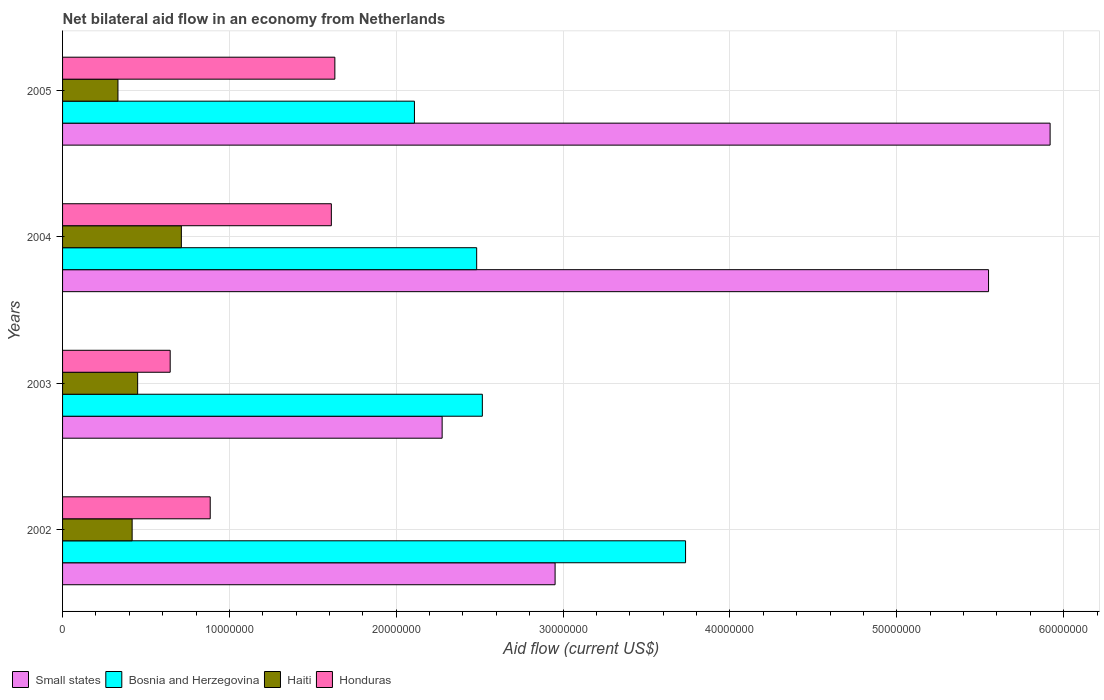How many different coloured bars are there?
Provide a succinct answer. 4. How many groups of bars are there?
Offer a very short reply. 4. Are the number of bars on each tick of the Y-axis equal?
Make the answer very short. Yes. How many bars are there on the 2nd tick from the top?
Your response must be concise. 4. What is the net bilateral aid flow in Small states in 2003?
Provide a succinct answer. 2.28e+07. Across all years, what is the maximum net bilateral aid flow in Haiti?
Offer a very short reply. 7.12e+06. Across all years, what is the minimum net bilateral aid flow in Small states?
Provide a succinct answer. 2.28e+07. What is the total net bilateral aid flow in Haiti in the graph?
Give a very brief answer. 1.91e+07. What is the difference between the net bilateral aid flow in Honduras in 2004 and that in 2005?
Your response must be concise. -2.10e+05. What is the difference between the net bilateral aid flow in Haiti in 2005 and the net bilateral aid flow in Bosnia and Herzegovina in 2002?
Make the answer very short. -3.40e+07. What is the average net bilateral aid flow in Bosnia and Herzegovina per year?
Your answer should be compact. 2.71e+07. In the year 2002, what is the difference between the net bilateral aid flow in Honduras and net bilateral aid flow in Bosnia and Herzegovina?
Give a very brief answer. -2.85e+07. In how many years, is the net bilateral aid flow in Bosnia and Herzegovina greater than 28000000 US$?
Offer a terse response. 1. What is the ratio of the net bilateral aid flow in Honduras in 2002 to that in 2003?
Offer a very short reply. 1.37. What is the difference between the highest and the second highest net bilateral aid flow in Small states?
Your answer should be compact. 3.69e+06. What is the difference between the highest and the lowest net bilateral aid flow in Small states?
Keep it short and to the point. 3.64e+07. In how many years, is the net bilateral aid flow in Honduras greater than the average net bilateral aid flow in Honduras taken over all years?
Provide a short and direct response. 2. Is the sum of the net bilateral aid flow in Honduras in 2002 and 2005 greater than the maximum net bilateral aid flow in Small states across all years?
Your response must be concise. No. Is it the case that in every year, the sum of the net bilateral aid flow in Bosnia and Herzegovina and net bilateral aid flow in Haiti is greater than the sum of net bilateral aid flow in Honduras and net bilateral aid flow in Small states?
Your response must be concise. No. What does the 1st bar from the top in 2003 represents?
Your answer should be very brief. Honduras. What does the 3rd bar from the bottom in 2003 represents?
Provide a succinct answer. Haiti. Is it the case that in every year, the sum of the net bilateral aid flow in Haiti and net bilateral aid flow in Small states is greater than the net bilateral aid flow in Honduras?
Provide a succinct answer. Yes. How many bars are there?
Offer a terse response. 16. Are all the bars in the graph horizontal?
Make the answer very short. Yes. What is the difference between two consecutive major ticks on the X-axis?
Provide a succinct answer. 1.00e+07. Does the graph contain any zero values?
Provide a succinct answer. No. Does the graph contain grids?
Provide a succinct answer. Yes. How many legend labels are there?
Offer a terse response. 4. How are the legend labels stacked?
Offer a terse response. Horizontal. What is the title of the graph?
Make the answer very short. Net bilateral aid flow in an economy from Netherlands. What is the label or title of the Y-axis?
Provide a short and direct response. Years. What is the Aid flow (current US$) in Small states in 2002?
Keep it short and to the point. 2.95e+07. What is the Aid flow (current US$) of Bosnia and Herzegovina in 2002?
Offer a very short reply. 3.73e+07. What is the Aid flow (current US$) of Haiti in 2002?
Keep it short and to the point. 4.17e+06. What is the Aid flow (current US$) in Honduras in 2002?
Give a very brief answer. 8.85e+06. What is the Aid flow (current US$) in Small states in 2003?
Make the answer very short. 2.28e+07. What is the Aid flow (current US$) in Bosnia and Herzegovina in 2003?
Your answer should be compact. 2.52e+07. What is the Aid flow (current US$) in Haiti in 2003?
Make the answer very short. 4.50e+06. What is the Aid flow (current US$) in Honduras in 2003?
Offer a very short reply. 6.45e+06. What is the Aid flow (current US$) of Small states in 2004?
Offer a very short reply. 5.55e+07. What is the Aid flow (current US$) of Bosnia and Herzegovina in 2004?
Make the answer very short. 2.48e+07. What is the Aid flow (current US$) in Haiti in 2004?
Ensure brevity in your answer.  7.12e+06. What is the Aid flow (current US$) in Honduras in 2004?
Ensure brevity in your answer.  1.61e+07. What is the Aid flow (current US$) of Small states in 2005?
Provide a succinct answer. 5.92e+07. What is the Aid flow (current US$) of Bosnia and Herzegovina in 2005?
Give a very brief answer. 2.11e+07. What is the Aid flow (current US$) of Haiti in 2005?
Provide a short and direct response. 3.32e+06. What is the Aid flow (current US$) of Honduras in 2005?
Your response must be concise. 1.63e+07. Across all years, what is the maximum Aid flow (current US$) of Small states?
Make the answer very short. 5.92e+07. Across all years, what is the maximum Aid flow (current US$) of Bosnia and Herzegovina?
Offer a very short reply. 3.73e+07. Across all years, what is the maximum Aid flow (current US$) of Haiti?
Offer a very short reply. 7.12e+06. Across all years, what is the maximum Aid flow (current US$) of Honduras?
Your answer should be compact. 1.63e+07. Across all years, what is the minimum Aid flow (current US$) in Small states?
Your response must be concise. 2.28e+07. Across all years, what is the minimum Aid flow (current US$) in Bosnia and Herzegovina?
Your answer should be very brief. 2.11e+07. Across all years, what is the minimum Aid flow (current US$) of Haiti?
Offer a terse response. 3.32e+06. Across all years, what is the minimum Aid flow (current US$) in Honduras?
Give a very brief answer. 6.45e+06. What is the total Aid flow (current US$) of Small states in the graph?
Provide a succinct answer. 1.67e+08. What is the total Aid flow (current US$) of Bosnia and Herzegovina in the graph?
Offer a very short reply. 1.08e+08. What is the total Aid flow (current US$) of Haiti in the graph?
Make the answer very short. 1.91e+07. What is the total Aid flow (current US$) of Honduras in the graph?
Ensure brevity in your answer.  4.77e+07. What is the difference between the Aid flow (current US$) of Small states in 2002 and that in 2003?
Provide a succinct answer. 6.77e+06. What is the difference between the Aid flow (current US$) of Bosnia and Herzegovina in 2002 and that in 2003?
Provide a succinct answer. 1.22e+07. What is the difference between the Aid flow (current US$) in Haiti in 2002 and that in 2003?
Offer a very short reply. -3.30e+05. What is the difference between the Aid flow (current US$) of Honduras in 2002 and that in 2003?
Offer a terse response. 2.40e+06. What is the difference between the Aid flow (current US$) in Small states in 2002 and that in 2004?
Offer a very short reply. -2.60e+07. What is the difference between the Aid flow (current US$) in Bosnia and Herzegovina in 2002 and that in 2004?
Offer a terse response. 1.25e+07. What is the difference between the Aid flow (current US$) in Haiti in 2002 and that in 2004?
Give a very brief answer. -2.95e+06. What is the difference between the Aid flow (current US$) of Honduras in 2002 and that in 2004?
Your response must be concise. -7.26e+06. What is the difference between the Aid flow (current US$) in Small states in 2002 and that in 2005?
Keep it short and to the point. -2.97e+07. What is the difference between the Aid flow (current US$) in Bosnia and Herzegovina in 2002 and that in 2005?
Give a very brief answer. 1.62e+07. What is the difference between the Aid flow (current US$) in Haiti in 2002 and that in 2005?
Make the answer very short. 8.50e+05. What is the difference between the Aid flow (current US$) in Honduras in 2002 and that in 2005?
Your answer should be very brief. -7.47e+06. What is the difference between the Aid flow (current US$) in Small states in 2003 and that in 2004?
Ensure brevity in your answer.  -3.28e+07. What is the difference between the Aid flow (current US$) in Bosnia and Herzegovina in 2003 and that in 2004?
Provide a short and direct response. 3.40e+05. What is the difference between the Aid flow (current US$) of Haiti in 2003 and that in 2004?
Make the answer very short. -2.62e+06. What is the difference between the Aid flow (current US$) in Honduras in 2003 and that in 2004?
Give a very brief answer. -9.66e+06. What is the difference between the Aid flow (current US$) in Small states in 2003 and that in 2005?
Your answer should be very brief. -3.64e+07. What is the difference between the Aid flow (current US$) in Bosnia and Herzegovina in 2003 and that in 2005?
Your response must be concise. 4.07e+06. What is the difference between the Aid flow (current US$) in Haiti in 2003 and that in 2005?
Your answer should be compact. 1.18e+06. What is the difference between the Aid flow (current US$) in Honduras in 2003 and that in 2005?
Offer a very short reply. -9.87e+06. What is the difference between the Aid flow (current US$) in Small states in 2004 and that in 2005?
Offer a terse response. -3.69e+06. What is the difference between the Aid flow (current US$) in Bosnia and Herzegovina in 2004 and that in 2005?
Keep it short and to the point. 3.73e+06. What is the difference between the Aid flow (current US$) in Haiti in 2004 and that in 2005?
Your response must be concise. 3.80e+06. What is the difference between the Aid flow (current US$) of Honduras in 2004 and that in 2005?
Your response must be concise. -2.10e+05. What is the difference between the Aid flow (current US$) in Small states in 2002 and the Aid flow (current US$) in Bosnia and Herzegovina in 2003?
Make the answer very short. 4.36e+06. What is the difference between the Aid flow (current US$) of Small states in 2002 and the Aid flow (current US$) of Haiti in 2003?
Ensure brevity in your answer.  2.50e+07. What is the difference between the Aid flow (current US$) of Small states in 2002 and the Aid flow (current US$) of Honduras in 2003?
Offer a terse response. 2.31e+07. What is the difference between the Aid flow (current US$) of Bosnia and Herzegovina in 2002 and the Aid flow (current US$) of Haiti in 2003?
Your answer should be compact. 3.28e+07. What is the difference between the Aid flow (current US$) in Bosnia and Herzegovina in 2002 and the Aid flow (current US$) in Honduras in 2003?
Ensure brevity in your answer.  3.09e+07. What is the difference between the Aid flow (current US$) in Haiti in 2002 and the Aid flow (current US$) in Honduras in 2003?
Provide a succinct answer. -2.28e+06. What is the difference between the Aid flow (current US$) of Small states in 2002 and the Aid flow (current US$) of Bosnia and Herzegovina in 2004?
Your response must be concise. 4.70e+06. What is the difference between the Aid flow (current US$) of Small states in 2002 and the Aid flow (current US$) of Haiti in 2004?
Give a very brief answer. 2.24e+07. What is the difference between the Aid flow (current US$) in Small states in 2002 and the Aid flow (current US$) in Honduras in 2004?
Keep it short and to the point. 1.34e+07. What is the difference between the Aid flow (current US$) in Bosnia and Herzegovina in 2002 and the Aid flow (current US$) in Haiti in 2004?
Your answer should be very brief. 3.02e+07. What is the difference between the Aid flow (current US$) of Bosnia and Herzegovina in 2002 and the Aid flow (current US$) of Honduras in 2004?
Keep it short and to the point. 2.12e+07. What is the difference between the Aid flow (current US$) of Haiti in 2002 and the Aid flow (current US$) of Honduras in 2004?
Give a very brief answer. -1.19e+07. What is the difference between the Aid flow (current US$) of Small states in 2002 and the Aid flow (current US$) of Bosnia and Herzegovina in 2005?
Provide a short and direct response. 8.43e+06. What is the difference between the Aid flow (current US$) in Small states in 2002 and the Aid flow (current US$) in Haiti in 2005?
Provide a short and direct response. 2.62e+07. What is the difference between the Aid flow (current US$) in Small states in 2002 and the Aid flow (current US$) in Honduras in 2005?
Your response must be concise. 1.32e+07. What is the difference between the Aid flow (current US$) of Bosnia and Herzegovina in 2002 and the Aid flow (current US$) of Haiti in 2005?
Ensure brevity in your answer.  3.40e+07. What is the difference between the Aid flow (current US$) in Bosnia and Herzegovina in 2002 and the Aid flow (current US$) in Honduras in 2005?
Keep it short and to the point. 2.10e+07. What is the difference between the Aid flow (current US$) in Haiti in 2002 and the Aid flow (current US$) in Honduras in 2005?
Offer a very short reply. -1.22e+07. What is the difference between the Aid flow (current US$) in Small states in 2003 and the Aid flow (current US$) in Bosnia and Herzegovina in 2004?
Ensure brevity in your answer.  -2.07e+06. What is the difference between the Aid flow (current US$) in Small states in 2003 and the Aid flow (current US$) in Haiti in 2004?
Offer a terse response. 1.56e+07. What is the difference between the Aid flow (current US$) of Small states in 2003 and the Aid flow (current US$) of Honduras in 2004?
Ensure brevity in your answer.  6.64e+06. What is the difference between the Aid flow (current US$) of Bosnia and Herzegovina in 2003 and the Aid flow (current US$) of Haiti in 2004?
Your response must be concise. 1.80e+07. What is the difference between the Aid flow (current US$) in Bosnia and Herzegovina in 2003 and the Aid flow (current US$) in Honduras in 2004?
Make the answer very short. 9.05e+06. What is the difference between the Aid flow (current US$) in Haiti in 2003 and the Aid flow (current US$) in Honduras in 2004?
Provide a succinct answer. -1.16e+07. What is the difference between the Aid flow (current US$) of Small states in 2003 and the Aid flow (current US$) of Bosnia and Herzegovina in 2005?
Keep it short and to the point. 1.66e+06. What is the difference between the Aid flow (current US$) of Small states in 2003 and the Aid flow (current US$) of Haiti in 2005?
Provide a succinct answer. 1.94e+07. What is the difference between the Aid flow (current US$) of Small states in 2003 and the Aid flow (current US$) of Honduras in 2005?
Your answer should be compact. 6.43e+06. What is the difference between the Aid flow (current US$) in Bosnia and Herzegovina in 2003 and the Aid flow (current US$) in Haiti in 2005?
Offer a very short reply. 2.18e+07. What is the difference between the Aid flow (current US$) of Bosnia and Herzegovina in 2003 and the Aid flow (current US$) of Honduras in 2005?
Your answer should be very brief. 8.84e+06. What is the difference between the Aid flow (current US$) in Haiti in 2003 and the Aid flow (current US$) in Honduras in 2005?
Your response must be concise. -1.18e+07. What is the difference between the Aid flow (current US$) of Small states in 2004 and the Aid flow (current US$) of Bosnia and Herzegovina in 2005?
Offer a very short reply. 3.44e+07. What is the difference between the Aid flow (current US$) of Small states in 2004 and the Aid flow (current US$) of Haiti in 2005?
Your answer should be compact. 5.22e+07. What is the difference between the Aid flow (current US$) in Small states in 2004 and the Aid flow (current US$) in Honduras in 2005?
Offer a very short reply. 3.92e+07. What is the difference between the Aid flow (current US$) in Bosnia and Herzegovina in 2004 and the Aid flow (current US$) in Haiti in 2005?
Provide a short and direct response. 2.15e+07. What is the difference between the Aid flow (current US$) of Bosnia and Herzegovina in 2004 and the Aid flow (current US$) of Honduras in 2005?
Your response must be concise. 8.50e+06. What is the difference between the Aid flow (current US$) of Haiti in 2004 and the Aid flow (current US$) of Honduras in 2005?
Your answer should be very brief. -9.20e+06. What is the average Aid flow (current US$) of Small states per year?
Your answer should be compact. 4.17e+07. What is the average Aid flow (current US$) of Bosnia and Herzegovina per year?
Provide a short and direct response. 2.71e+07. What is the average Aid flow (current US$) of Haiti per year?
Keep it short and to the point. 4.78e+06. What is the average Aid flow (current US$) in Honduras per year?
Your answer should be compact. 1.19e+07. In the year 2002, what is the difference between the Aid flow (current US$) in Small states and Aid flow (current US$) in Bosnia and Herzegovina?
Your answer should be very brief. -7.82e+06. In the year 2002, what is the difference between the Aid flow (current US$) in Small states and Aid flow (current US$) in Haiti?
Your answer should be very brief. 2.54e+07. In the year 2002, what is the difference between the Aid flow (current US$) in Small states and Aid flow (current US$) in Honduras?
Your answer should be very brief. 2.07e+07. In the year 2002, what is the difference between the Aid flow (current US$) in Bosnia and Herzegovina and Aid flow (current US$) in Haiti?
Provide a succinct answer. 3.32e+07. In the year 2002, what is the difference between the Aid flow (current US$) of Bosnia and Herzegovina and Aid flow (current US$) of Honduras?
Offer a very short reply. 2.85e+07. In the year 2002, what is the difference between the Aid flow (current US$) in Haiti and Aid flow (current US$) in Honduras?
Give a very brief answer. -4.68e+06. In the year 2003, what is the difference between the Aid flow (current US$) in Small states and Aid flow (current US$) in Bosnia and Herzegovina?
Your answer should be compact. -2.41e+06. In the year 2003, what is the difference between the Aid flow (current US$) in Small states and Aid flow (current US$) in Haiti?
Offer a terse response. 1.82e+07. In the year 2003, what is the difference between the Aid flow (current US$) in Small states and Aid flow (current US$) in Honduras?
Provide a succinct answer. 1.63e+07. In the year 2003, what is the difference between the Aid flow (current US$) in Bosnia and Herzegovina and Aid flow (current US$) in Haiti?
Your response must be concise. 2.07e+07. In the year 2003, what is the difference between the Aid flow (current US$) in Bosnia and Herzegovina and Aid flow (current US$) in Honduras?
Offer a terse response. 1.87e+07. In the year 2003, what is the difference between the Aid flow (current US$) of Haiti and Aid flow (current US$) of Honduras?
Offer a very short reply. -1.95e+06. In the year 2004, what is the difference between the Aid flow (current US$) in Small states and Aid flow (current US$) in Bosnia and Herzegovina?
Ensure brevity in your answer.  3.07e+07. In the year 2004, what is the difference between the Aid flow (current US$) in Small states and Aid flow (current US$) in Haiti?
Offer a very short reply. 4.84e+07. In the year 2004, what is the difference between the Aid flow (current US$) in Small states and Aid flow (current US$) in Honduras?
Your answer should be very brief. 3.94e+07. In the year 2004, what is the difference between the Aid flow (current US$) of Bosnia and Herzegovina and Aid flow (current US$) of Haiti?
Make the answer very short. 1.77e+07. In the year 2004, what is the difference between the Aid flow (current US$) in Bosnia and Herzegovina and Aid flow (current US$) in Honduras?
Give a very brief answer. 8.71e+06. In the year 2004, what is the difference between the Aid flow (current US$) of Haiti and Aid flow (current US$) of Honduras?
Keep it short and to the point. -8.99e+06. In the year 2005, what is the difference between the Aid flow (current US$) of Small states and Aid flow (current US$) of Bosnia and Herzegovina?
Offer a terse response. 3.81e+07. In the year 2005, what is the difference between the Aid flow (current US$) in Small states and Aid flow (current US$) in Haiti?
Give a very brief answer. 5.59e+07. In the year 2005, what is the difference between the Aid flow (current US$) in Small states and Aid flow (current US$) in Honduras?
Keep it short and to the point. 4.29e+07. In the year 2005, what is the difference between the Aid flow (current US$) of Bosnia and Herzegovina and Aid flow (current US$) of Haiti?
Provide a short and direct response. 1.78e+07. In the year 2005, what is the difference between the Aid flow (current US$) in Bosnia and Herzegovina and Aid flow (current US$) in Honduras?
Give a very brief answer. 4.77e+06. In the year 2005, what is the difference between the Aid flow (current US$) of Haiti and Aid flow (current US$) of Honduras?
Provide a succinct answer. -1.30e+07. What is the ratio of the Aid flow (current US$) of Small states in 2002 to that in 2003?
Your answer should be compact. 1.3. What is the ratio of the Aid flow (current US$) in Bosnia and Herzegovina in 2002 to that in 2003?
Give a very brief answer. 1.48. What is the ratio of the Aid flow (current US$) in Haiti in 2002 to that in 2003?
Your response must be concise. 0.93. What is the ratio of the Aid flow (current US$) in Honduras in 2002 to that in 2003?
Keep it short and to the point. 1.37. What is the ratio of the Aid flow (current US$) in Small states in 2002 to that in 2004?
Offer a very short reply. 0.53. What is the ratio of the Aid flow (current US$) in Bosnia and Herzegovina in 2002 to that in 2004?
Your answer should be very brief. 1.5. What is the ratio of the Aid flow (current US$) in Haiti in 2002 to that in 2004?
Offer a terse response. 0.59. What is the ratio of the Aid flow (current US$) of Honduras in 2002 to that in 2004?
Give a very brief answer. 0.55. What is the ratio of the Aid flow (current US$) in Small states in 2002 to that in 2005?
Ensure brevity in your answer.  0.5. What is the ratio of the Aid flow (current US$) in Bosnia and Herzegovina in 2002 to that in 2005?
Your response must be concise. 1.77. What is the ratio of the Aid flow (current US$) of Haiti in 2002 to that in 2005?
Offer a very short reply. 1.26. What is the ratio of the Aid flow (current US$) of Honduras in 2002 to that in 2005?
Offer a very short reply. 0.54. What is the ratio of the Aid flow (current US$) in Small states in 2003 to that in 2004?
Provide a succinct answer. 0.41. What is the ratio of the Aid flow (current US$) in Bosnia and Herzegovina in 2003 to that in 2004?
Offer a very short reply. 1.01. What is the ratio of the Aid flow (current US$) in Haiti in 2003 to that in 2004?
Offer a very short reply. 0.63. What is the ratio of the Aid flow (current US$) in Honduras in 2003 to that in 2004?
Ensure brevity in your answer.  0.4. What is the ratio of the Aid flow (current US$) in Small states in 2003 to that in 2005?
Offer a very short reply. 0.38. What is the ratio of the Aid flow (current US$) in Bosnia and Herzegovina in 2003 to that in 2005?
Your answer should be compact. 1.19. What is the ratio of the Aid flow (current US$) of Haiti in 2003 to that in 2005?
Make the answer very short. 1.36. What is the ratio of the Aid flow (current US$) of Honduras in 2003 to that in 2005?
Ensure brevity in your answer.  0.4. What is the ratio of the Aid flow (current US$) in Small states in 2004 to that in 2005?
Your response must be concise. 0.94. What is the ratio of the Aid flow (current US$) of Bosnia and Herzegovina in 2004 to that in 2005?
Make the answer very short. 1.18. What is the ratio of the Aid flow (current US$) in Haiti in 2004 to that in 2005?
Your answer should be compact. 2.14. What is the ratio of the Aid flow (current US$) in Honduras in 2004 to that in 2005?
Provide a succinct answer. 0.99. What is the difference between the highest and the second highest Aid flow (current US$) in Small states?
Provide a short and direct response. 3.69e+06. What is the difference between the highest and the second highest Aid flow (current US$) in Bosnia and Herzegovina?
Give a very brief answer. 1.22e+07. What is the difference between the highest and the second highest Aid flow (current US$) of Haiti?
Your answer should be compact. 2.62e+06. What is the difference between the highest and the lowest Aid flow (current US$) of Small states?
Give a very brief answer. 3.64e+07. What is the difference between the highest and the lowest Aid flow (current US$) in Bosnia and Herzegovina?
Give a very brief answer. 1.62e+07. What is the difference between the highest and the lowest Aid flow (current US$) in Haiti?
Your answer should be very brief. 3.80e+06. What is the difference between the highest and the lowest Aid flow (current US$) of Honduras?
Offer a very short reply. 9.87e+06. 